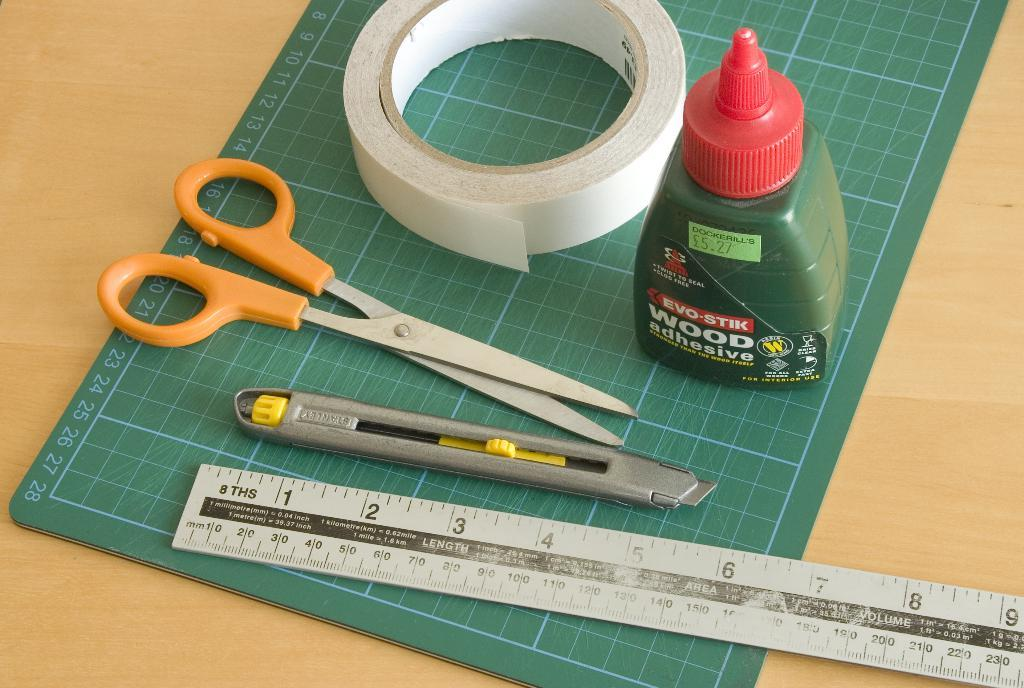<image>
Provide a brief description of the given image. A pair of scissors, a ruler, and a bottle of Evo-Stik wood adhesive on a green cutting board. 